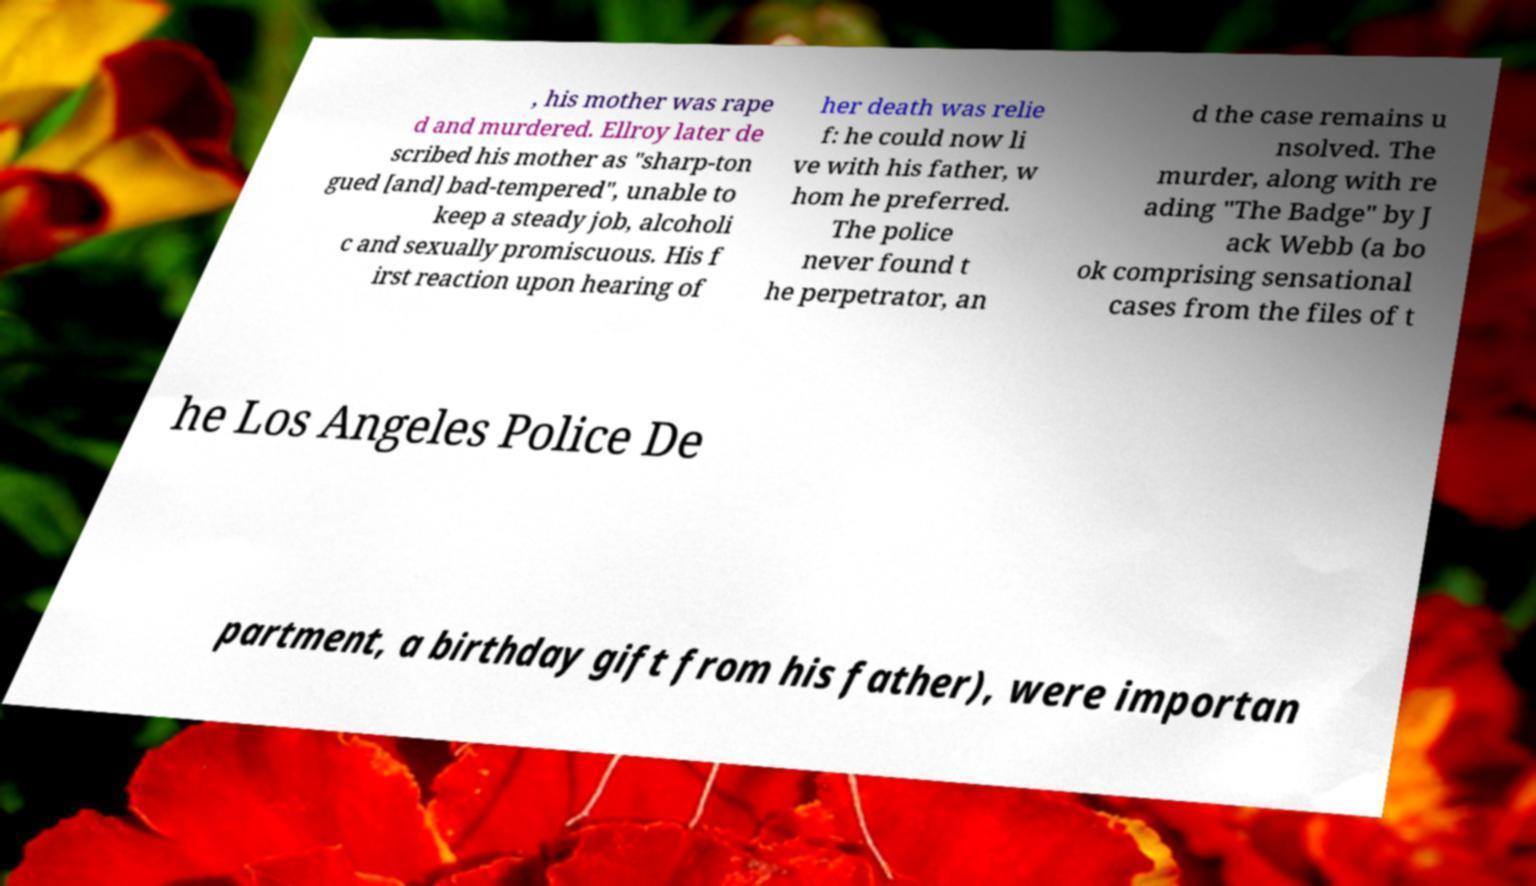There's text embedded in this image that I need extracted. Can you transcribe it verbatim? , his mother was rape d and murdered. Ellroy later de scribed his mother as "sharp-ton gued [and] bad-tempered", unable to keep a steady job, alcoholi c and sexually promiscuous. His f irst reaction upon hearing of her death was relie f: he could now li ve with his father, w hom he preferred. The police never found t he perpetrator, an d the case remains u nsolved. The murder, along with re ading "The Badge" by J ack Webb (a bo ok comprising sensational cases from the files of t he Los Angeles Police De partment, a birthday gift from his father), were importan 